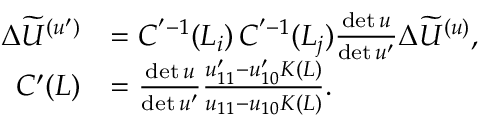<formula> <loc_0><loc_0><loc_500><loc_500>\begin{array} { r l } { \Delta \widetilde { U } ^ { ( u ^ { \prime } ) } } & { = C ^ { ^ { \prime } - 1 } ( L _ { i } ) \, C ^ { ^ { \prime } - 1 } ( L _ { j } ) \frac { d e t \, u } { d e t \, u ^ { \prime } } \Delta \widetilde { U } ^ { ( u ) } , } \\ { C ^ { \prime } ( L ) } & { = \frac { d e t \, u } { d e t \, u ^ { \prime } } \frac { u _ { 1 1 } ^ { \prime } - u _ { 1 0 } ^ { \prime } K ( L ) } { u _ { 1 1 } - u _ { 1 0 } K ( L ) } . } \end{array}</formula> 